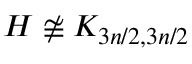Convert formula to latex. <formula><loc_0><loc_0><loc_500><loc_500>H \not \cong K _ { 3 n / 2 , 3 n / 2 }</formula> 